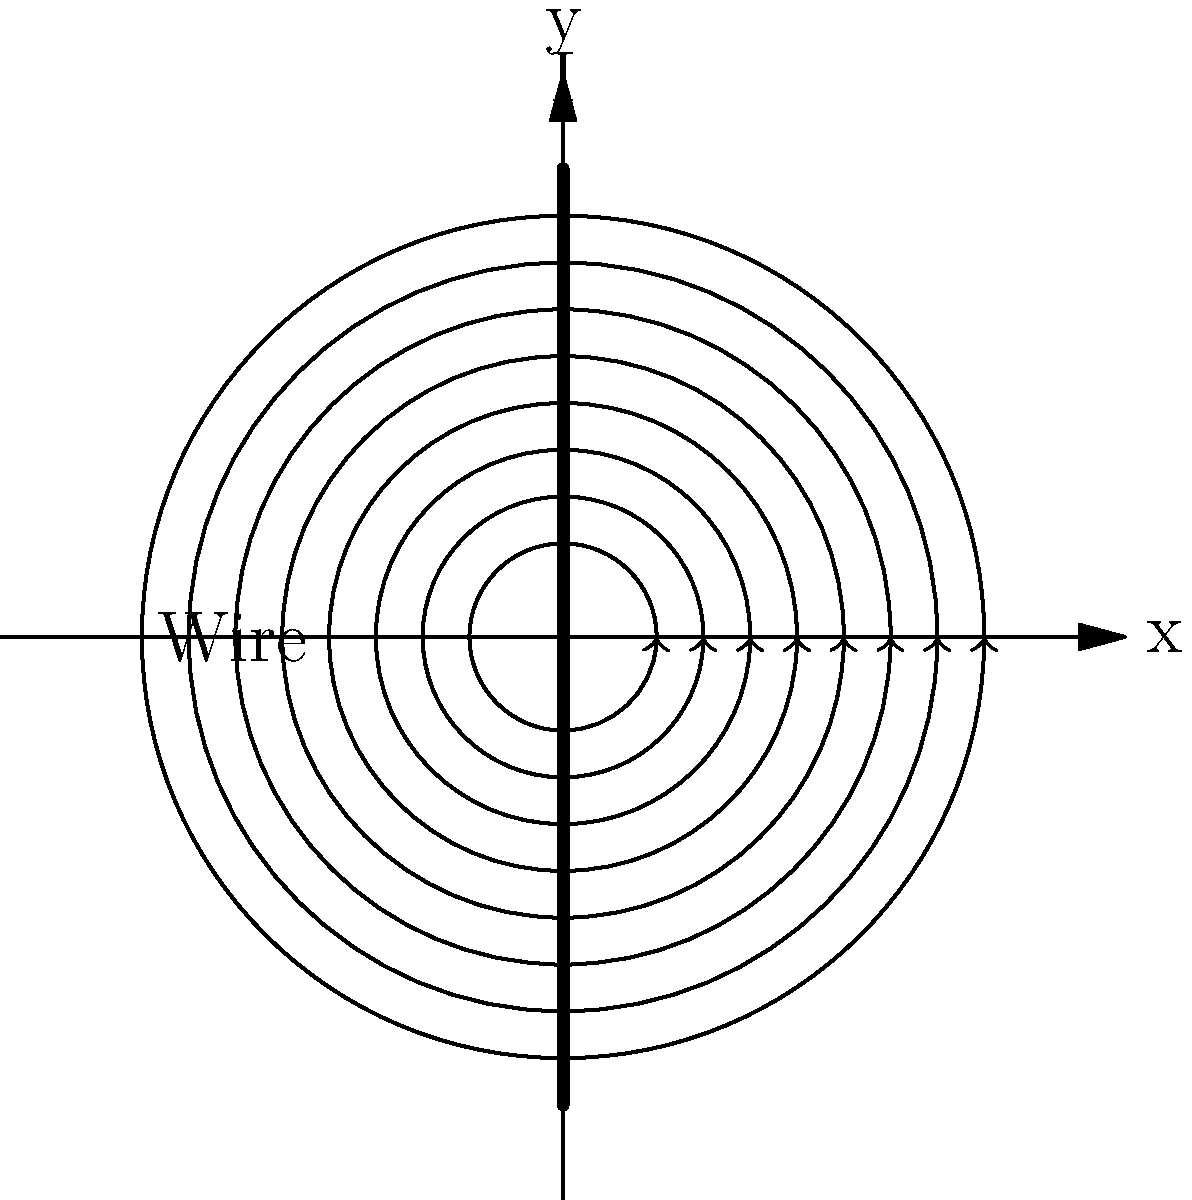As a fact-checker at Global Press Journal, you're reviewing an article about electromagnetic fields. The image shows magnetic field lines around a current-carrying wire. According to the right-hand rule, in which direction is the current flowing through the wire? To determine the direction of current flow, we can use the right-hand rule for a straight current-carrying wire. Here's a step-by-step explanation:

1. Observe the magnetic field lines:
   - The field lines are concentric circles around the wire.
   - The arrows on the field lines indicate a counterclockwise direction when viewed from above.

2. Apply the right-hand rule:
   - Imagine grabbing the wire with your right hand.
   - Orient your thumb along the wire in the direction of current flow.
   - Curl your fingers around the wire.

3. Match the finger curl to the field lines:
   - The curl of your fingers should match the direction of the magnetic field lines.
   - In this case, your fingers should curl counterclockwise when viewed from above.

4. Determine the thumb direction:
   - For your fingers to curl counterclockwise, your thumb must point upwards.

5. Conclude the current direction:
   - Since your thumb represents the current direction, the current must be flowing upwards in the wire.

Therefore, based on the counterclockwise magnetic field lines and the right-hand rule, the current is flowing upwards through the wire.
Answer: Upward 